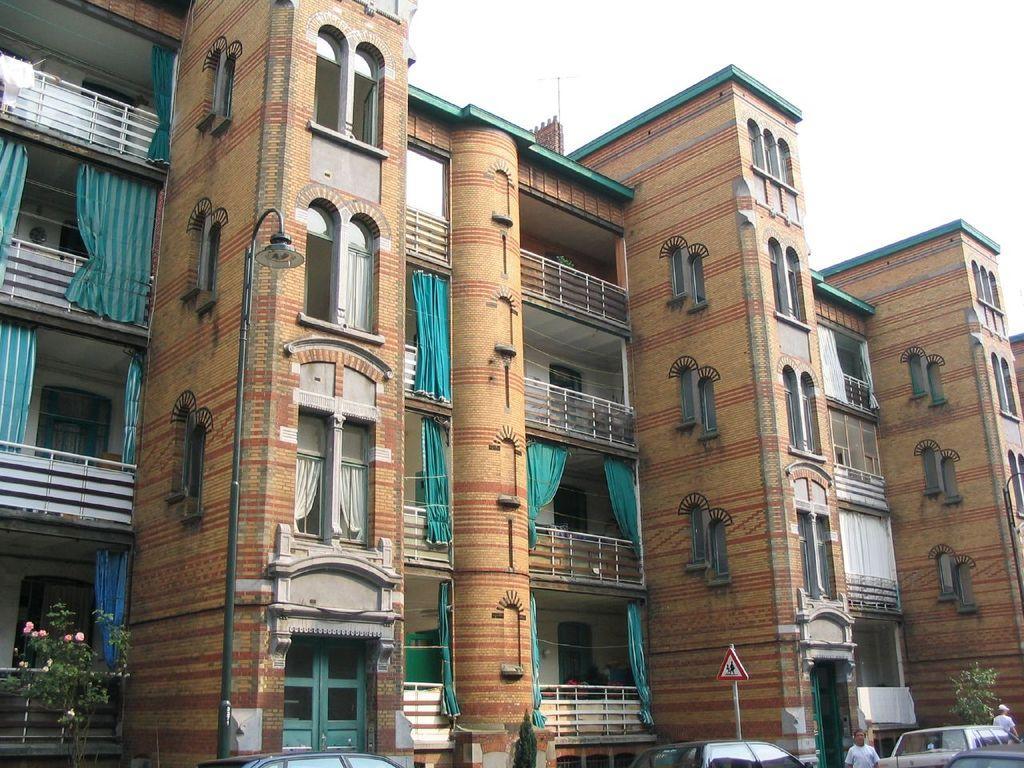Please provide a concise description of this image. This picture is clicked outside. In the foreground we can see the group of vehicles and some persons and we can see the flowers and trees, we can see a board is attached to the metal rod and we can see the buildings, windows and deck rails of the buildings and the curtains and a lamp attached to the metal rod. In the background we can see the sky. 